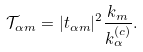<formula> <loc_0><loc_0><loc_500><loc_500>\mathcal { T } _ { \alpha m } = | t _ { \alpha m } | ^ { 2 } \frac { k _ { m } } { k _ { \alpha } ^ { \left ( c \right ) } } .</formula> 